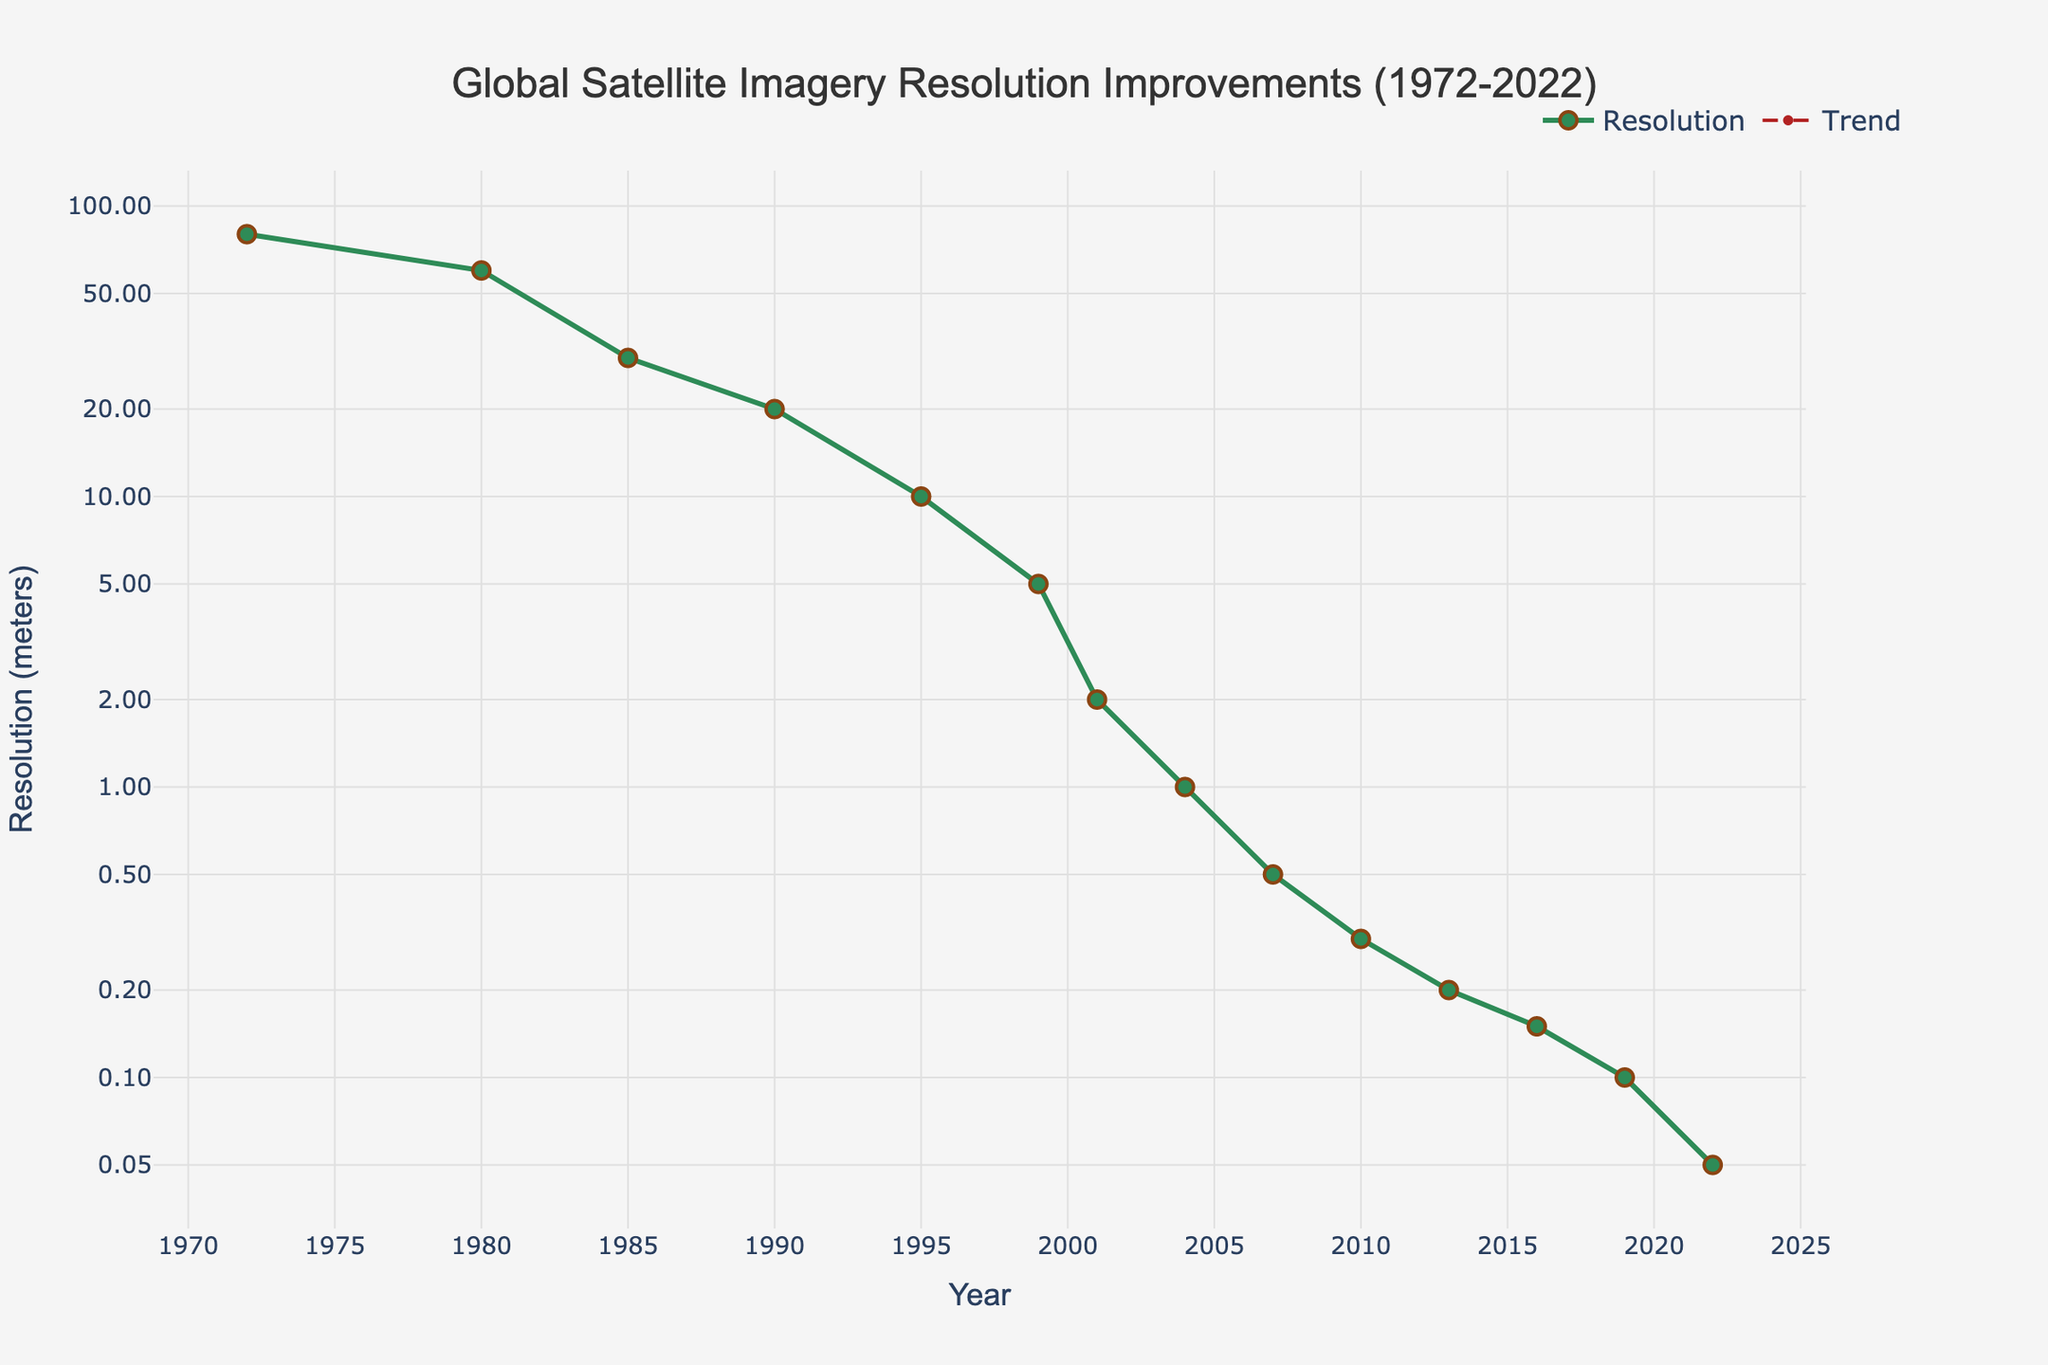What is the resolution improvement from 1980 to 2000? The resolution in 1980 was 60 meters, and by 2000 it improved to 2 meters. The improvement is 60 - 2 = 58 meters.
Answer: 58 meters In which year did the resolution reach 1 meter? The resolution reached 1 meter in 2004, as indicated by the data point for that year.
Answer: 2004 By how much did the satellite imagery resolution improve from 1995 to 2010? The resolution in 1995 was 10 meters, and in 2010 it improved to 0.3 meters. The improvement is 10 - 0.3 = 9.7 meters.
Answer: 9.7 meters What is the general trend in satellite resolution from 1972 to 2022? The general trend in satellite resolution from 1972 to 2022 is a logarithmic improvement, where the resolution improves significantly over the years.
Answer: Improvement Compare the resolution in 1985 and 1990. Which year had a better resolution, and by how much? The resolution in 1985 was 30 meters, and in 1990 it was 20 meters. Therefore, 1990 had a better resolution by 30 - 20 = 10 meters.
Answer: 1990, by 10 meters Which year saw the most significant improvement from the previous year, and what was the improvement? The most significant improvement was from 2001 (2 meters) to 2004 (1 meter), with an improvement of 2 - 1 = 1 meter.
Answer: 2004, 1 meter Describe the trendline added to the plot. What does it signify about the resolution improvements? The trendline in the plot is logarithmic, signifying that satellite resolution improvements follow a logarithmic pattern, with significant enhancements particularly in the earlier years.
Answer: Logarithmic trend, significant improvements How does the resolution value of 2007 compare to that of 2013? The resolution in 2007 was 0.5 meters, while in 2013 it was 0.2 meters. 2013 had a better resolution than 2007 by 0.5 - 0.2 = 0.3 meters.
Answer: 2013, by 0.3 meters What was the satellite resolution in the year 2019, and how does it compare to 2016? The resolution in 2019 was 0.1 meters, whereas in 2016 it was 0.15 meters. Therefore, 2019 had a better resolution by 0.15 - 0.1 = 0.05 meters.
Answer: 0.1 meters, better by 0.05 meters What is the average improvement in resolution per year from 1972 to 2022? The overall improvement from 1972 (80 meters) to 2022 (0.05 meters) is 80 - 0.05 = 79.95 meters over 50 years. The average annual improvement is 79.95 / 50 = 1.599 meters/year.
Answer: 1.599 meters/year 